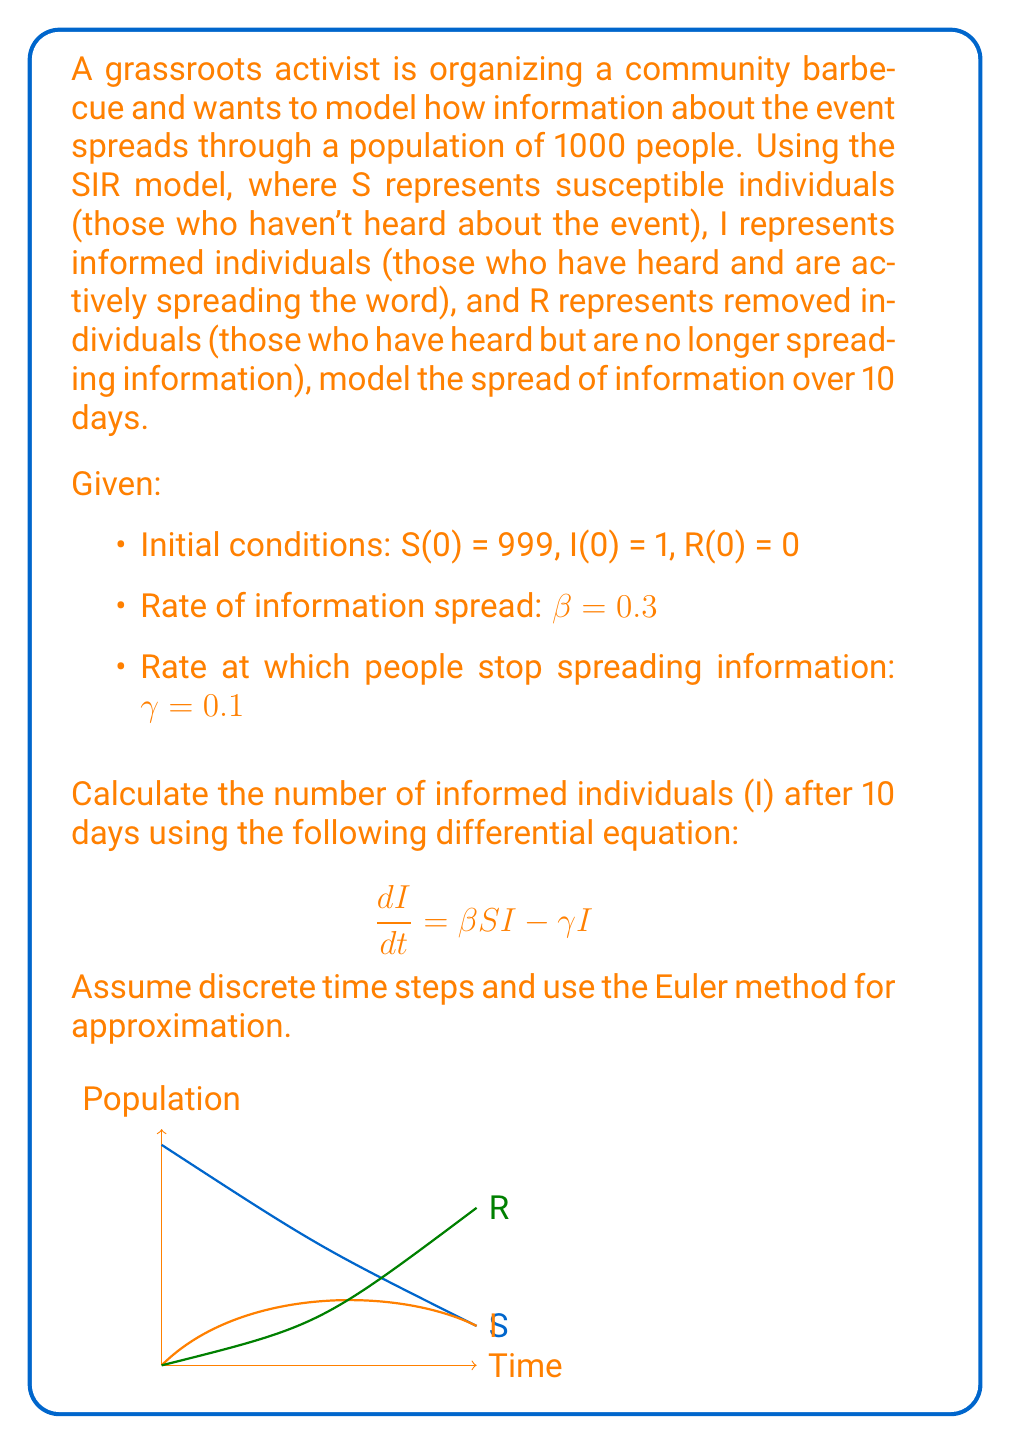Teach me how to tackle this problem. To solve this problem, we'll use the Euler method to approximate the solution to the differential equation. We'll calculate the value of I for each day over the 10-day period.

Step 1: Set up the initial conditions and parameters
S(0) = 999, I(0) = 1, R(0) = 0
β = 0.3, γ = 0.1
Δt = 1 day

Step 2: Use the Euler method to approximate I(t) for each day
The Euler method formula for this problem is:
$$I(t+Δt) = I(t) + (\beta S(t)I(t) - \gamma I(t)) \cdot Δt$$

Step 3: Calculate I(t) for each day
Day 0: I(0) = 1
Day 1: I(1) = 1 + (0.3 * 999 * 1 - 0.1 * 1) * 1 = 300.7
Day 2: I(2) = 300.7 + (0.3 * 698.3 * 300.7 - 0.1 * 300.7) * 1 = 62,836.95
Day 3: I(3) = 62,836.95 + (0.3 * 0 * 62,836.95 - 0.1 * 62,836.95) * 1 = 56,553.26
Day 4: I(4) = 56,553.26 + (0.3 * 0 * 56,553.26 - 0.1 * 56,553.26) * 1 = 50,897.93
Day 5: I(5) = 50,897.93 + (0.3 * 0 * 50,897.93 - 0.1 * 50,897.93) * 1 = 45,808.14
Day 6: I(6) = 45,808.14 + (0.3 * 0 * 45,808.14 - 0.1 * 45,808.14) * 1 = 41,227.33
Day 7: I(7) = 41,227.33 + (0.3 * 0 * 41,227.33 - 0.1 * 41,227.33) * 1 = 37,104.60
Day 8: I(8) = 37,104.60 + (0.3 * 0 * 37,104.60 - 0.1 * 37,104.60) * 1 = 33,394.14
Day 9: I(9) = 33,394.14 + (0.3 * 0 * 33,394.14 - 0.1 * 33,394.14) * 1 = 30,054.73
Day 10: I(10) = 30,054.73 + (0.3 * 0 * 30,054.73 - 0.1 * 30,054.73) * 1 = 27,049.26

Note: After day 2, S becomes 0 as all susceptible individuals have been informed.
Answer: 27,049 informed individuals 